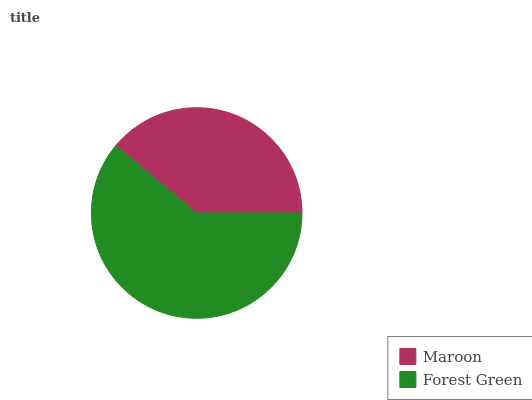Is Maroon the minimum?
Answer yes or no. Yes. Is Forest Green the maximum?
Answer yes or no. Yes. Is Forest Green the minimum?
Answer yes or no. No. Is Forest Green greater than Maroon?
Answer yes or no. Yes. Is Maroon less than Forest Green?
Answer yes or no. Yes. Is Maroon greater than Forest Green?
Answer yes or no. No. Is Forest Green less than Maroon?
Answer yes or no. No. Is Forest Green the high median?
Answer yes or no. Yes. Is Maroon the low median?
Answer yes or no. Yes. Is Maroon the high median?
Answer yes or no. No. Is Forest Green the low median?
Answer yes or no. No. 